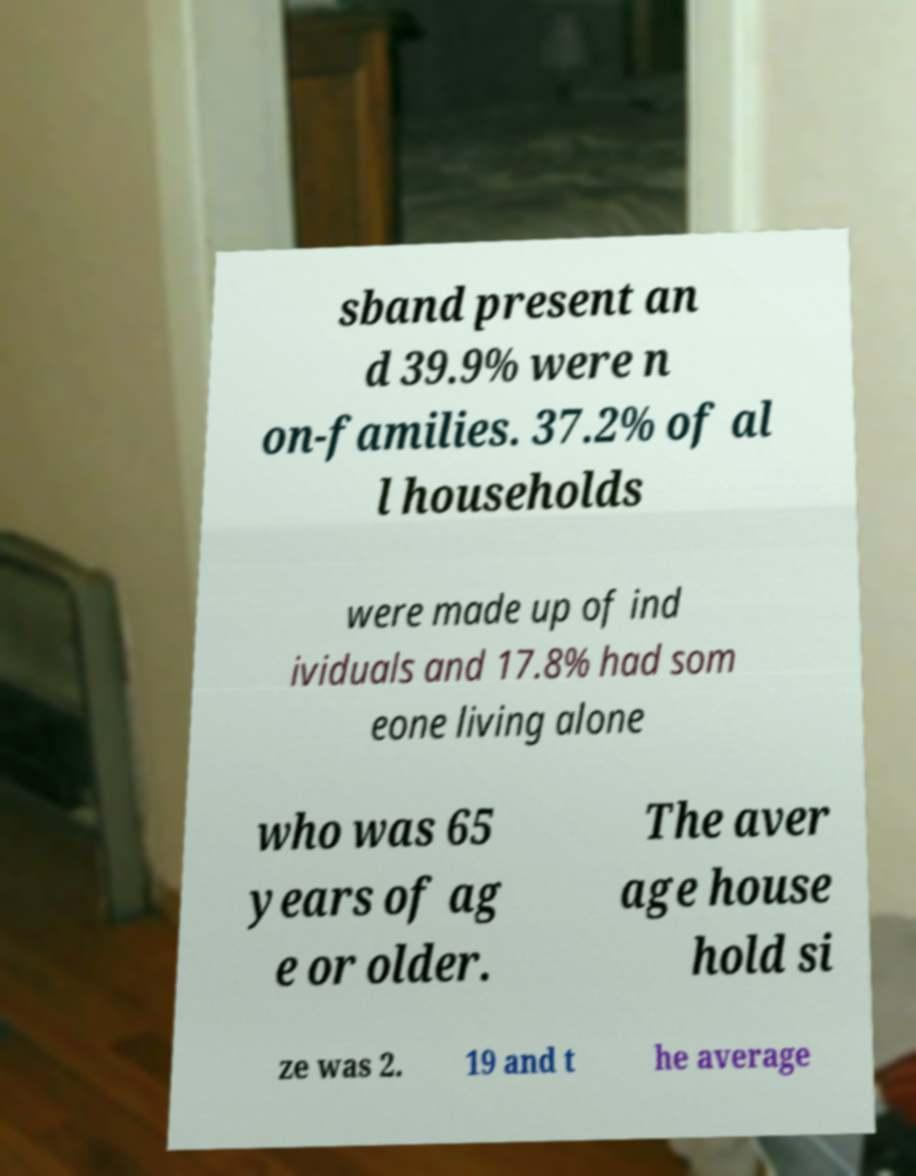Could you assist in decoding the text presented in this image and type it out clearly? sband present an d 39.9% were n on-families. 37.2% of al l households were made up of ind ividuals and 17.8% had som eone living alone who was 65 years of ag e or older. The aver age house hold si ze was 2. 19 and t he average 